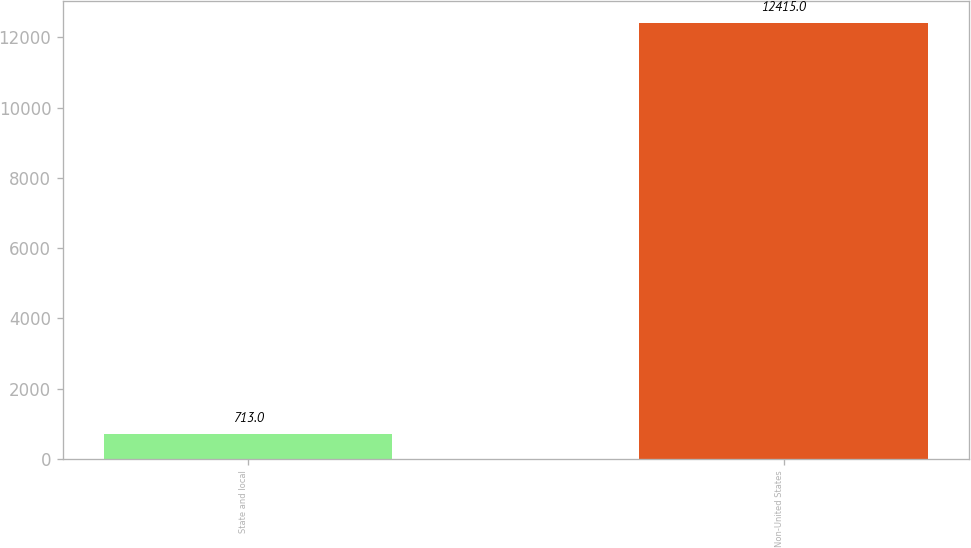Convert chart to OTSL. <chart><loc_0><loc_0><loc_500><loc_500><bar_chart><fcel>State and local<fcel>Non-United States<nl><fcel>713<fcel>12415<nl></chart> 